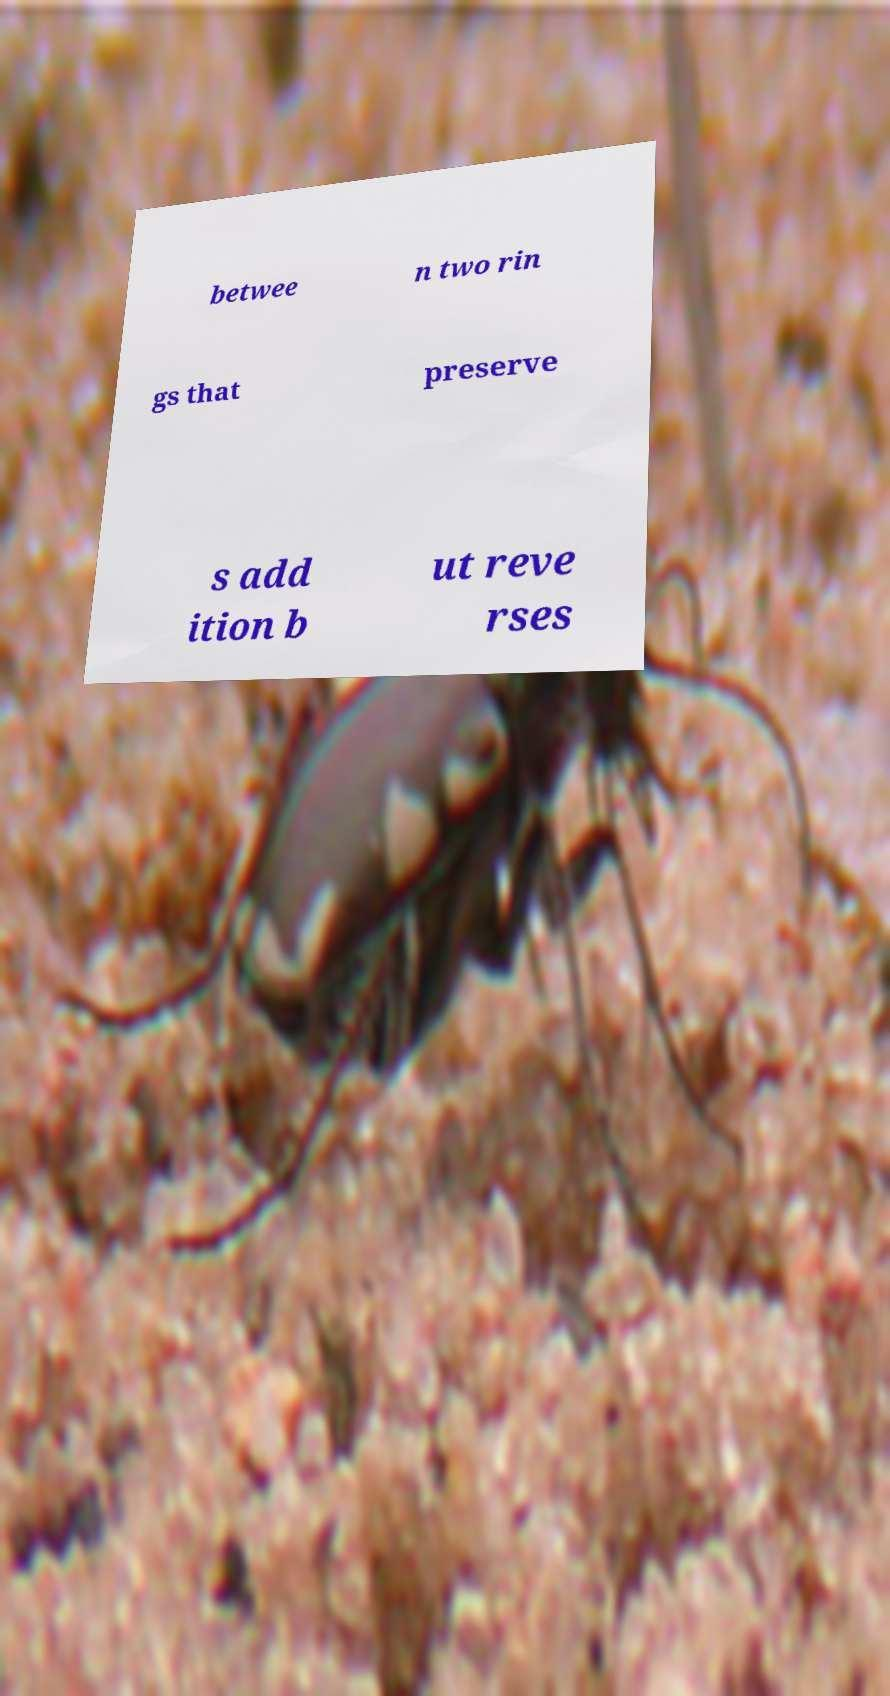Please identify and transcribe the text found in this image. betwee n two rin gs that preserve s add ition b ut reve rses 